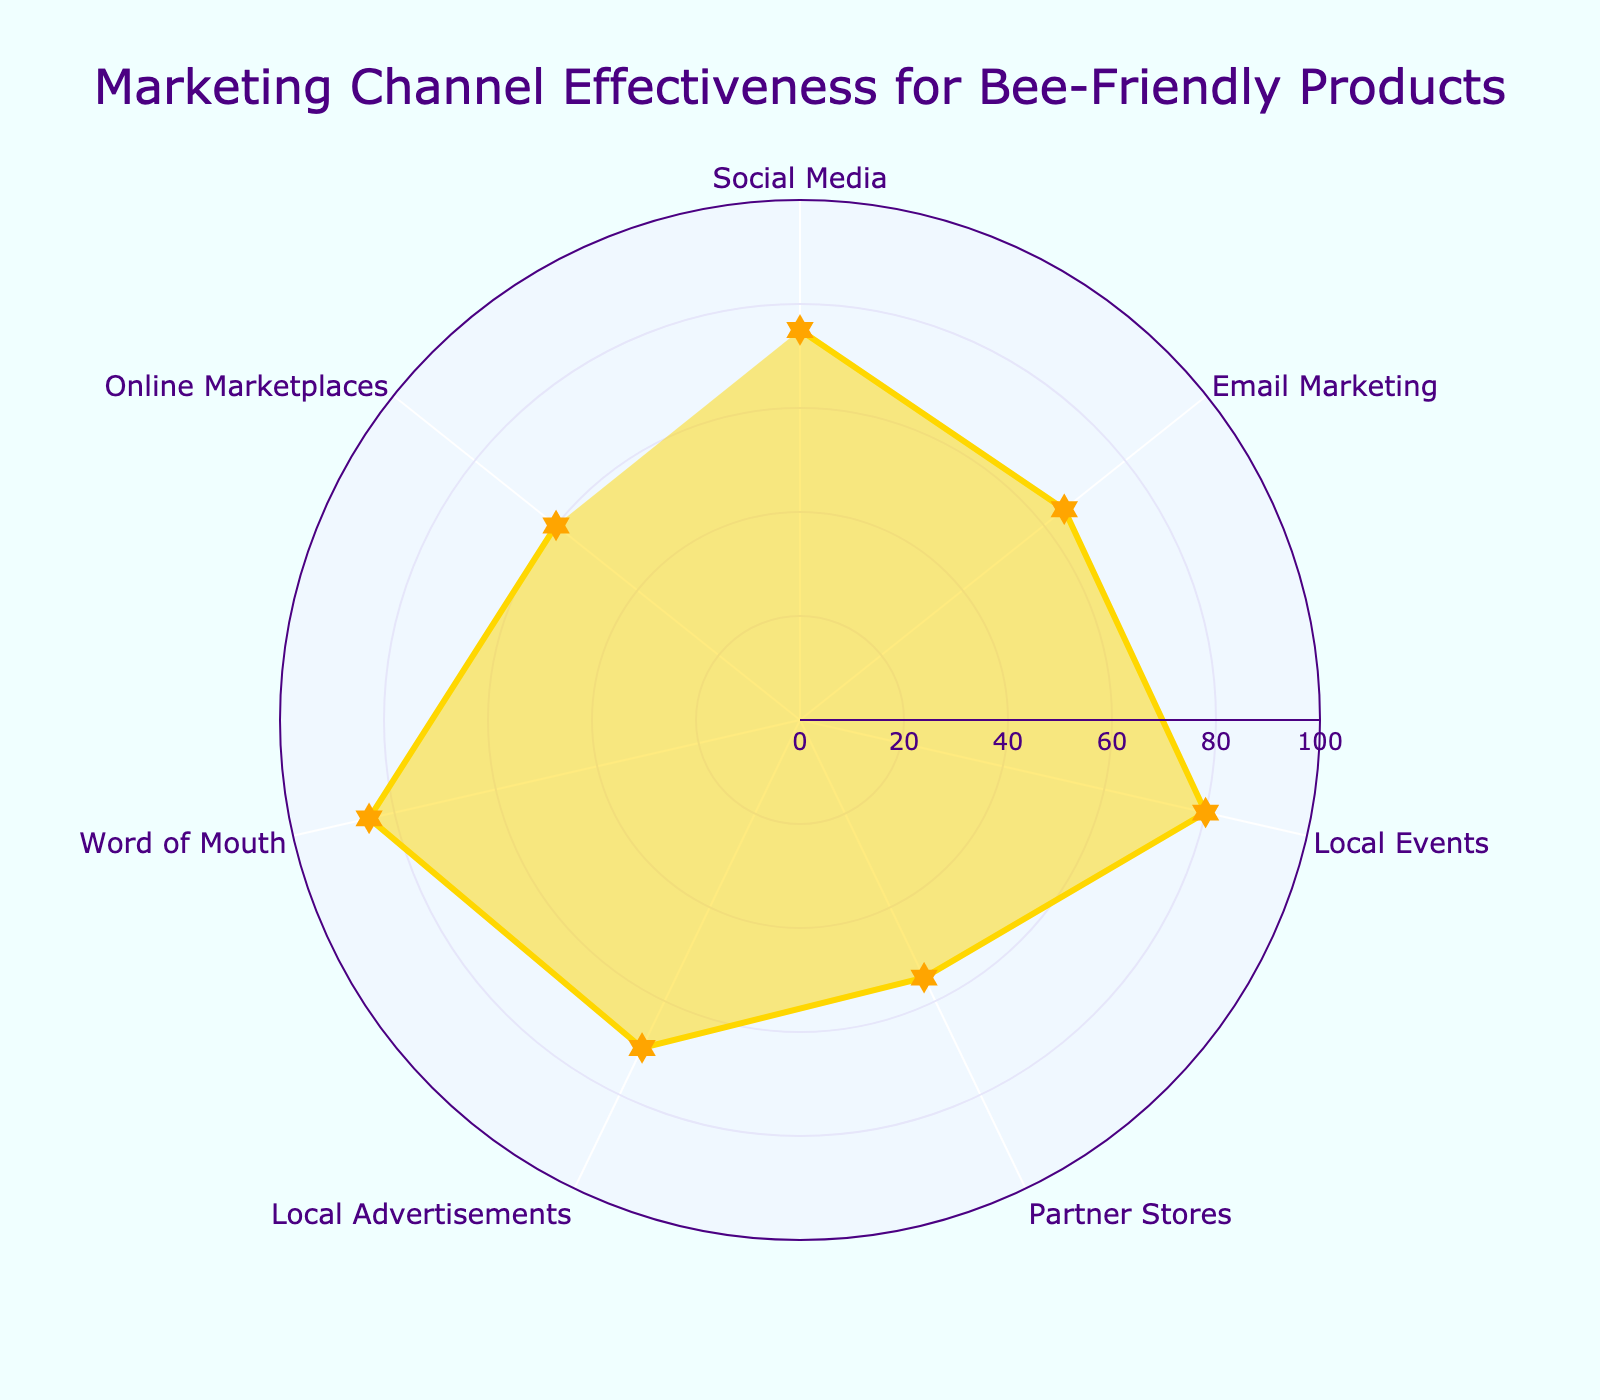What is the title of the chart? The title of the chart can be found at the top of the figure. The title is written in larger and more prominent font as compared to other text
Answer: "Marketing Channel Effectiveness for Bee-Friendly Products" How many marketing channels are displayed in the chart? To find the number of marketing channels, count the distinct labels along the angular axis. Each label represents a different marketing channel
Answer: 7 Which marketing channel has the highest effectiveness? Observe the radial axis values to find the channel with the longest radial line segment. The label corresponding to this segment represents the most effective marketing channel
Answer: Word of Mouth What is the effectiveness of Local Events? Identify the radial line segment labeled "Local Events" and read off the value on the radial axis
Answer: 80 Which marketing channel is least effective? Similar to identifying the most effective channel, find the shortest radial line segment and note its corresponding label
Answer: Partner Stores How much more effective is Social Media compared to Partner Stores? First, note the effectiveness values for Social Media and for Partner Stores. Then, subtract the latter from the former (75 - 55)
Answer: 20 What is the average effectiveness value of all the marketing channels? Sum the effectiveness values of all channels and then divide by the number of channels. The values are [75, 65, 80, 55, 70, 85, 60], so the calculation is (75+65+80+55+70+85+60)/7
Answer: 70 Which marketing channel is more effective: Email Marketing or Online Marketplaces? Compare the radial values of Email Marketing (65) and Online Marketplaces (60)
Answer: Email Marketing Is the effectiveness of Local Advertisements greater than the average effectiveness value? Local Advertisements has an effectiveness of 70. Calculate the average effectiveness value (previously found as 70) and compare
Answer: No List the marketing channels with an effectiveness value greater than 70. Identify and list the channels where the radial axis value is above 70. Look for Word of Mouth (85), Local Events (80), Social Media (75)
Answer: Word of Mouth, Social Media, Local Events 